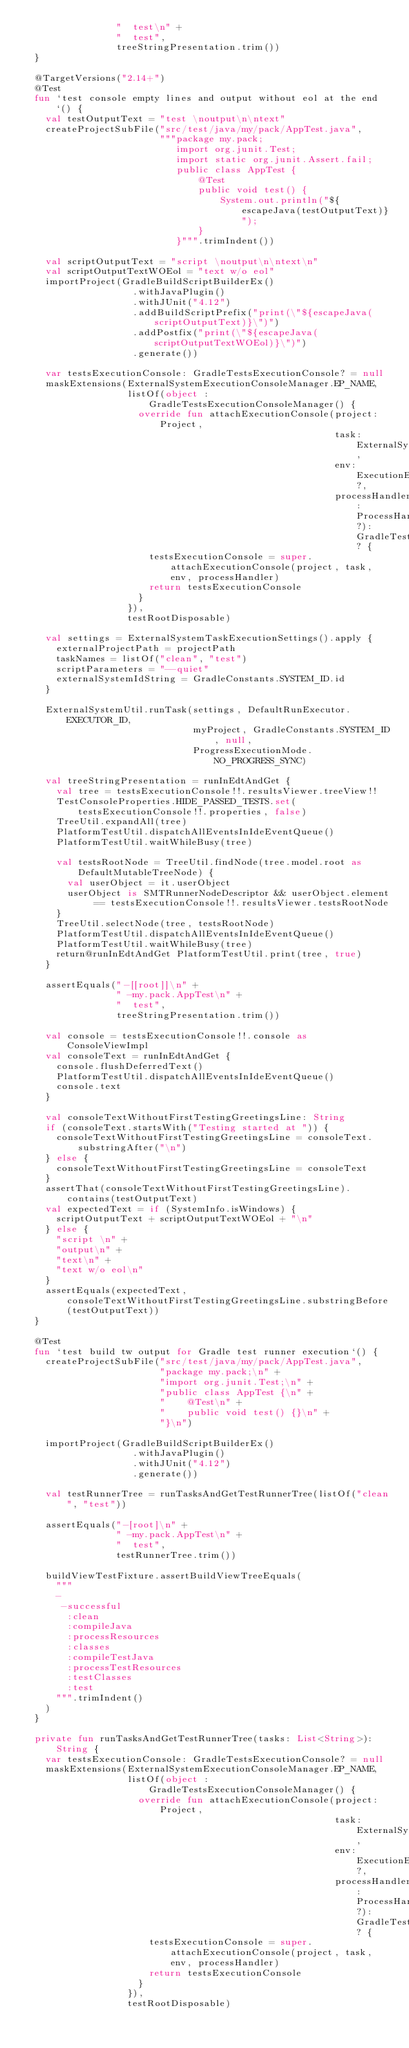<code> <loc_0><loc_0><loc_500><loc_500><_Kotlin_>                 "  test\n" +
                 "  test",
                 treeStringPresentation.trim())
  }

  @TargetVersions("2.14+")
  @Test
  fun `test console empty lines and output without eol at the end`() {
    val testOutputText = "test \noutput\n\ntext"
    createProjectSubFile("src/test/java/my/pack/AppTest.java",
                         """package my.pack;
                            import org.junit.Test;
                            import static org.junit.Assert.fail;
                            public class AppTest {
                                @Test
                                public void test() {
                                    System.out.println("${escapeJava(testOutputText)}");
                                }
                            }""".trimIndent())

    val scriptOutputText = "script \noutput\n\ntext\n"
    val scriptOutputTextWOEol = "text w/o eol"
    importProject(GradleBuildScriptBuilderEx()
                    .withJavaPlugin()
                    .withJUnit("4.12")
                    .addBuildScriptPrefix("print(\"${escapeJava(scriptOutputText)}\")")
                    .addPostfix("print(\"${escapeJava(scriptOutputTextWOEol)}\")")
                    .generate())

    var testsExecutionConsole: GradleTestsExecutionConsole? = null
    maskExtensions(ExternalSystemExecutionConsoleManager.EP_NAME,
                   listOf(object : GradleTestsExecutionConsoleManager() {
                     override fun attachExecutionConsole(project: Project,
                                                         task: ExternalSystemTask,
                                                         env: ExecutionEnvironment?,
                                                         processHandler: ProcessHandler?): GradleTestsExecutionConsole? {
                       testsExecutionConsole = super.attachExecutionConsole(project, task, env, processHandler)
                       return testsExecutionConsole
                     }
                   }),
                   testRootDisposable)

    val settings = ExternalSystemTaskExecutionSettings().apply {
      externalProjectPath = projectPath
      taskNames = listOf("clean", "test")
      scriptParameters = "--quiet"
      externalSystemIdString = GradleConstants.SYSTEM_ID.id
    }

    ExternalSystemUtil.runTask(settings, DefaultRunExecutor.EXECUTOR_ID,
                               myProject, GradleConstants.SYSTEM_ID, null,
                               ProgressExecutionMode.NO_PROGRESS_SYNC)

    val treeStringPresentation = runInEdtAndGet {
      val tree = testsExecutionConsole!!.resultsViewer.treeView!!
      TestConsoleProperties.HIDE_PASSED_TESTS.set(testsExecutionConsole!!.properties, false)
      TreeUtil.expandAll(tree)
      PlatformTestUtil.dispatchAllEventsInIdeEventQueue()
      PlatformTestUtil.waitWhileBusy(tree)

      val testsRootNode = TreeUtil.findNode(tree.model.root as DefaultMutableTreeNode) {
        val userObject = it.userObject
        userObject is SMTRunnerNodeDescriptor && userObject.element == testsExecutionConsole!!.resultsViewer.testsRootNode
      }
      TreeUtil.selectNode(tree, testsRootNode)
      PlatformTestUtil.dispatchAllEventsInIdeEventQueue()
      PlatformTestUtil.waitWhileBusy(tree)
      return@runInEdtAndGet PlatformTestUtil.print(tree, true)
    }

    assertEquals("-[[root]]\n" +
                 " -my.pack.AppTest\n" +
                 "  test",
                 treeStringPresentation.trim())

    val console = testsExecutionConsole!!.console as ConsoleViewImpl
    val consoleText = runInEdtAndGet {
      console.flushDeferredText()
      PlatformTestUtil.dispatchAllEventsInIdeEventQueue()
      console.text
    }

    val consoleTextWithoutFirstTestingGreetingsLine: String
    if (consoleText.startsWith("Testing started at ")) {
      consoleTextWithoutFirstTestingGreetingsLine = consoleText.substringAfter("\n")
    } else {
      consoleTextWithoutFirstTestingGreetingsLine = consoleText
    }
    assertThat(consoleTextWithoutFirstTestingGreetingsLine).contains(testOutputText)
    val expectedText = if (SystemInfo.isWindows) {
      scriptOutputText + scriptOutputTextWOEol + "\n"
    } else {
      "script \n" +
      "output\n" +
      "text\n" +
      "text w/o eol\n"
    }
    assertEquals(expectedText, consoleTextWithoutFirstTestingGreetingsLine.substringBefore(testOutputText))
  }

  @Test
  fun `test build tw output for Gradle test runner execution`() {
    createProjectSubFile("src/test/java/my/pack/AppTest.java",
                         "package my.pack;\n" +
                         "import org.junit.Test;\n" +
                         "public class AppTest {\n" +
                         "    @Test\n" +
                         "    public void test() {}\n" +
                         "}\n")

    importProject(GradleBuildScriptBuilderEx()
                    .withJavaPlugin()
                    .withJUnit("4.12")
                    .generate())

    val testRunnerTree = runTasksAndGetTestRunnerTree(listOf("clean", "test"))

    assertEquals("-[root]\n" +
                 " -my.pack.AppTest\n" +
                 "  test",
                 testRunnerTree.trim())

    buildViewTestFixture.assertBuildViewTreeEquals(
      """
      -
       -successful
        :clean
        :compileJava
        :processResources
        :classes
        :compileTestJava
        :processTestResources
        :testClasses
        :test
      """.trimIndent()
    )
  }

  private fun runTasksAndGetTestRunnerTree(tasks: List<String>): String {
    var testsExecutionConsole: GradleTestsExecutionConsole? = null
    maskExtensions(ExternalSystemExecutionConsoleManager.EP_NAME,
                   listOf(object : GradleTestsExecutionConsoleManager() {
                     override fun attachExecutionConsole(project: Project,
                                                         task: ExternalSystemTask,
                                                         env: ExecutionEnvironment?,
                                                         processHandler: ProcessHandler?): GradleTestsExecutionConsole? {
                       testsExecutionConsole = super.attachExecutionConsole(project, task, env, processHandler)
                       return testsExecutionConsole
                     }
                   }),
                   testRootDisposable)
</code> 